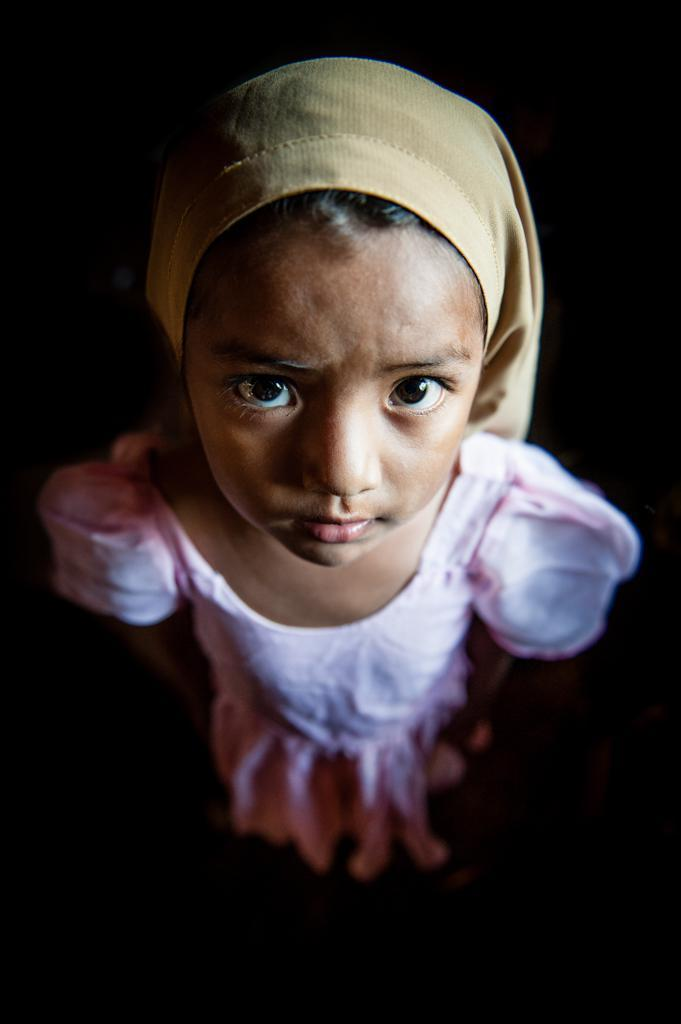What is the main subject of the image? The main subject of the image is a baby. What is the baby wearing? The baby is wearing a pink dress and a cap. What is the baby's posture in the image? The baby is standing. What is the baby's focus in the image? The baby is watching something. How would you describe the background of the image? The background of the image is dark in color. What type of wrench is the baby holding in the image? There is no wrench present in the image; the baby is wearing a pink dress and a cap, standing, and watching something. Who is the baby's father in the image? There is no information about the baby's father in the image. 